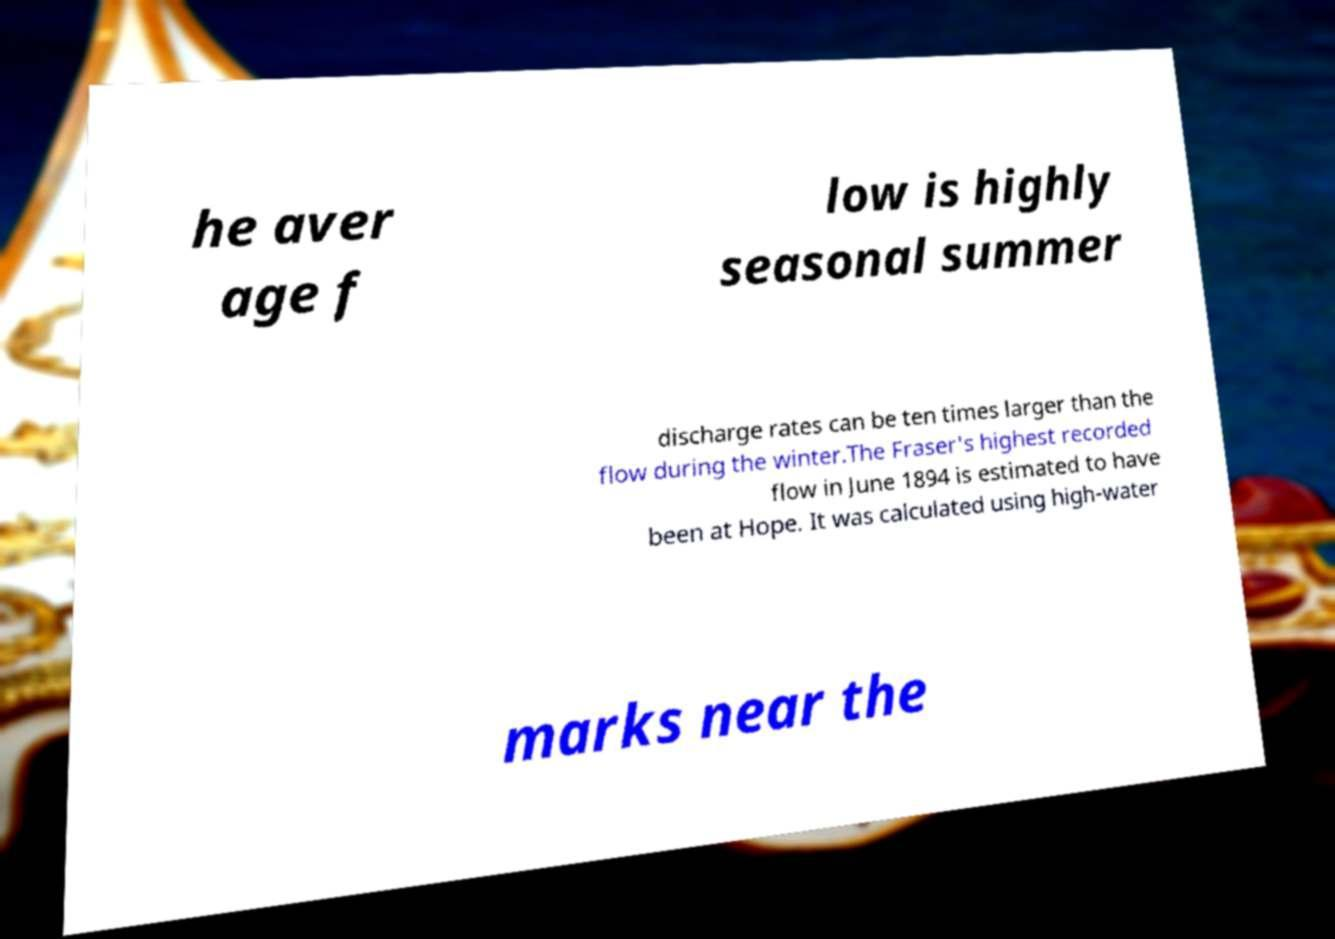Please read and relay the text visible in this image. What does it say? he aver age f low is highly seasonal summer discharge rates can be ten times larger than the flow during the winter.The Fraser's highest recorded flow in June 1894 is estimated to have been at Hope. It was calculated using high-water marks near the 